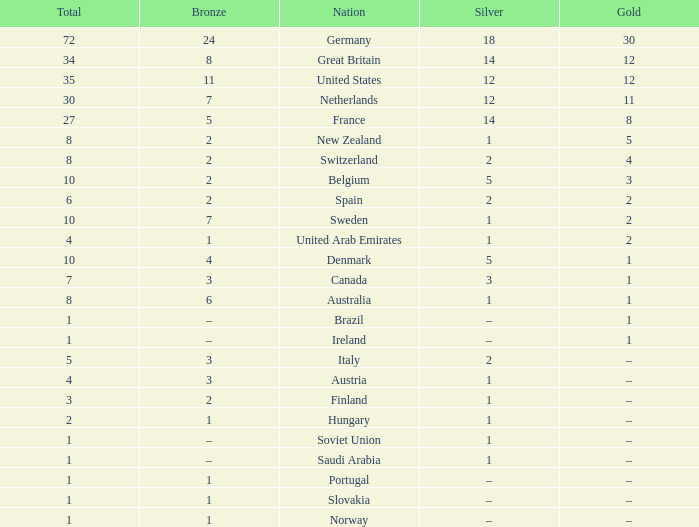What is Gold, when Silver is 5, and when Nation is Belgium? 3.0. 